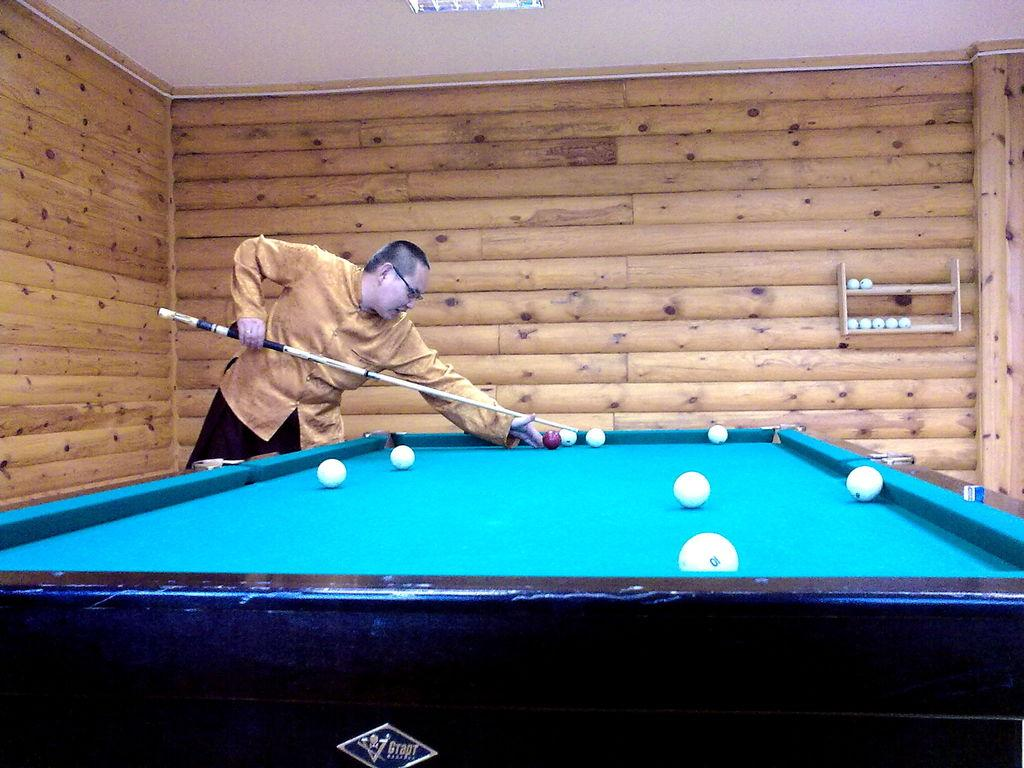Who is the person in the image? There is a man in the image. What is the man doing in the image? The man is playing snookers. On what surface is the snookers being played? The snookers are being played on a snooker board. What can be seen in the background of the image? There is a wooden wall in the background of the image. What is the source of light in the image? There is a light visible at the top of the image. What type of grain is being harvested in the image? There is no grain or harvesting visible in the image; it features a man playing snookers. 